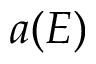Convert formula to latex. <formula><loc_0><loc_0><loc_500><loc_500>a ( E )</formula> 